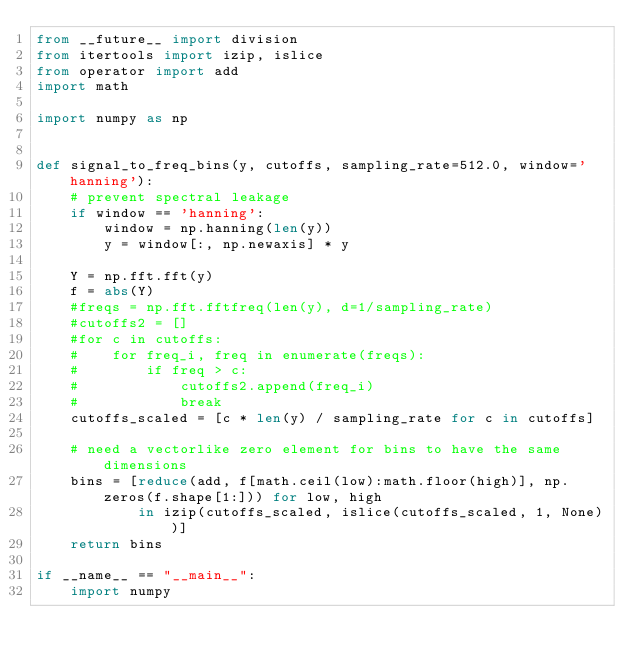<code> <loc_0><loc_0><loc_500><loc_500><_Python_>from __future__ import division
from itertools import izip, islice
from operator import add
import math

import numpy as np


def signal_to_freq_bins(y, cutoffs, sampling_rate=512.0, window='hanning'):
    # prevent spectral leakage
    if window == 'hanning':
        window = np.hanning(len(y))
        y = window[:, np.newaxis] * y

    Y = np.fft.fft(y)
    f = abs(Y)
    #freqs = np.fft.fftfreq(len(y), d=1/sampling_rate)
    #cutoffs2 = []
    #for c in cutoffs:
    #    for freq_i, freq in enumerate(freqs):
    #        if freq > c:
    #            cutoffs2.append(freq_i)
    #            break
    cutoffs_scaled = [c * len(y) / sampling_rate for c in cutoffs]

    # need a vectorlike zero element for bins to have the same dimensions
    bins = [reduce(add, f[math.ceil(low):math.floor(high)], np.zeros(f.shape[1:])) for low, high
            in izip(cutoffs_scaled, islice(cutoffs_scaled, 1, None))]
    return bins

if __name__ == "__main__":
    import numpy</code> 